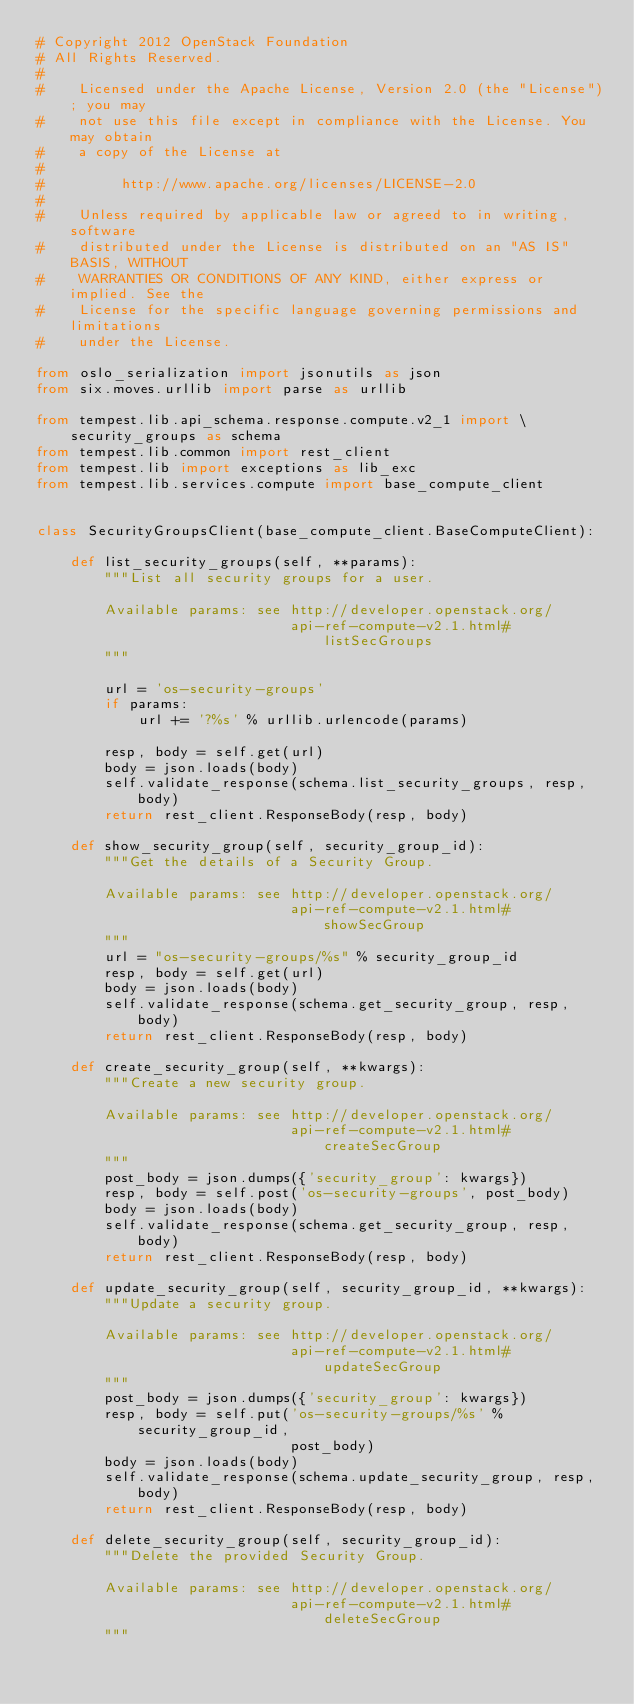<code> <loc_0><loc_0><loc_500><loc_500><_Python_># Copyright 2012 OpenStack Foundation
# All Rights Reserved.
#
#    Licensed under the Apache License, Version 2.0 (the "License"); you may
#    not use this file except in compliance with the License. You may obtain
#    a copy of the License at
#
#         http://www.apache.org/licenses/LICENSE-2.0
#
#    Unless required by applicable law or agreed to in writing, software
#    distributed under the License is distributed on an "AS IS" BASIS, WITHOUT
#    WARRANTIES OR CONDITIONS OF ANY KIND, either express or implied. See the
#    License for the specific language governing permissions and limitations
#    under the License.

from oslo_serialization import jsonutils as json
from six.moves.urllib import parse as urllib

from tempest.lib.api_schema.response.compute.v2_1 import \
    security_groups as schema
from tempest.lib.common import rest_client
from tempest.lib import exceptions as lib_exc
from tempest.lib.services.compute import base_compute_client


class SecurityGroupsClient(base_compute_client.BaseComputeClient):

    def list_security_groups(self, **params):
        """List all security groups for a user.

        Available params: see http://developer.openstack.org/
                              api-ref-compute-v2.1.html#listSecGroups
        """

        url = 'os-security-groups'
        if params:
            url += '?%s' % urllib.urlencode(params)

        resp, body = self.get(url)
        body = json.loads(body)
        self.validate_response(schema.list_security_groups, resp, body)
        return rest_client.ResponseBody(resp, body)

    def show_security_group(self, security_group_id):
        """Get the details of a Security Group.

        Available params: see http://developer.openstack.org/
                              api-ref-compute-v2.1.html#showSecGroup
        """
        url = "os-security-groups/%s" % security_group_id
        resp, body = self.get(url)
        body = json.loads(body)
        self.validate_response(schema.get_security_group, resp, body)
        return rest_client.ResponseBody(resp, body)

    def create_security_group(self, **kwargs):
        """Create a new security group.

        Available params: see http://developer.openstack.org/
                              api-ref-compute-v2.1.html#createSecGroup
        """
        post_body = json.dumps({'security_group': kwargs})
        resp, body = self.post('os-security-groups', post_body)
        body = json.loads(body)
        self.validate_response(schema.get_security_group, resp, body)
        return rest_client.ResponseBody(resp, body)

    def update_security_group(self, security_group_id, **kwargs):
        """Update a security group.

        Available params: see http://developer.openstack.org/
                              api-ref-compute-v2.1.html#updateSecGroup
        """
        post_body = json.dumps({'security_group': kwargs})
        resp, body = self.put('os-security-groups/%s' % security_group_id,
                              post_body)
        body = json.loads(body)
        self.validate_response(schema.update_security_group, resp, body)
        return rest_client.ResponseBody(resp, body)

    def delete_security_group(self, security_group_id):
        """Delete the provided Security Group.

        Available params: see http://developer.openstack.org/
                              api-ref-compute-v2.1.html#deleteSecGroup
        """</code> 